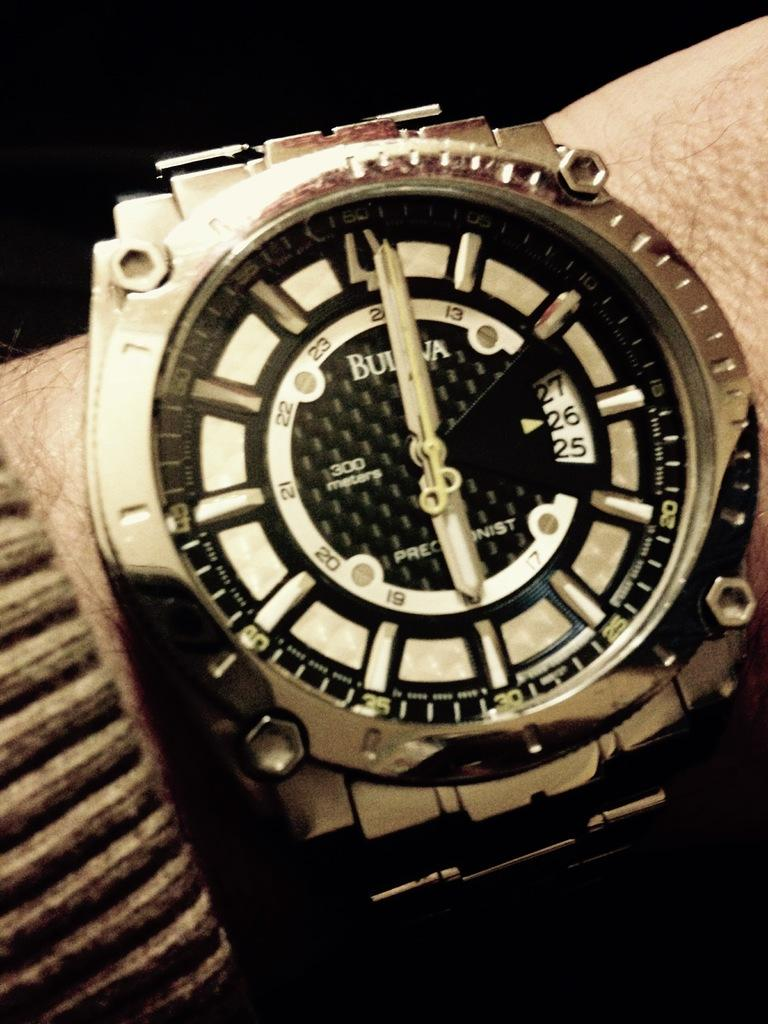<image>
Summarize the visual content of the image. A Bulova watch says it is six o'clock 